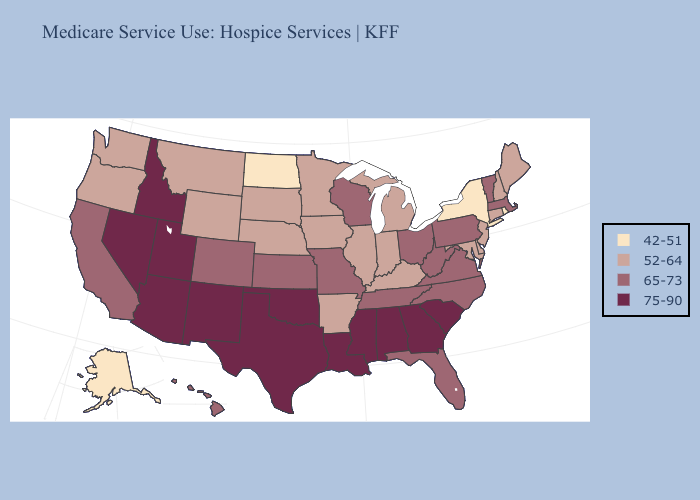Does the map have missing data?
Quick response, please. No. Does the first symbol in the legend represent the smallest category?
Write a very short answer. Yes. Does North Dakota have the highest value in the USA?
Keep it brief. No. What is the highest value in the MidWest ?
Give a very brief answer. 65-73. What is the value of Oregon?
Write a very short answer. 52-64. What is the highest value in the USA?
Short answer required. 75-90. What is the highest value in the South ?
Give a very brief answer. 75-90. What is the value of New Hampshire?
Quick response, please. 52-64. What is the value of Wyoming?
Keep it brief. 52-64. Among the states that border Idaho , does Nevada have the highest value?
Give a very brief answer. Yes. Does Washington have a lower value than Oklahoma?
Concise answer only. Yes. Name the states that have a value in the range 75-90?
Quick response, please. Alabama, Arizona, Georgia, Idaho, Louisiana, Mississippi, Nevada, New Mexico, Oklahoma, South Carolina, Texas, Utah. Name the states that have a value in the range 42-51?
Give a very brief answer. Alaska, New York, North Dakota, Rhode Island. How many symbols are there in the legend?
Concise answer only. 4. Which states have the highest value in the USA?
Keep it brief. Alabama, Arizona, Georgia, Idaho, Louisiana, Mississippi, Nevada, New Mexico, Oklahoma, South Carolina, Texas, Utah. 